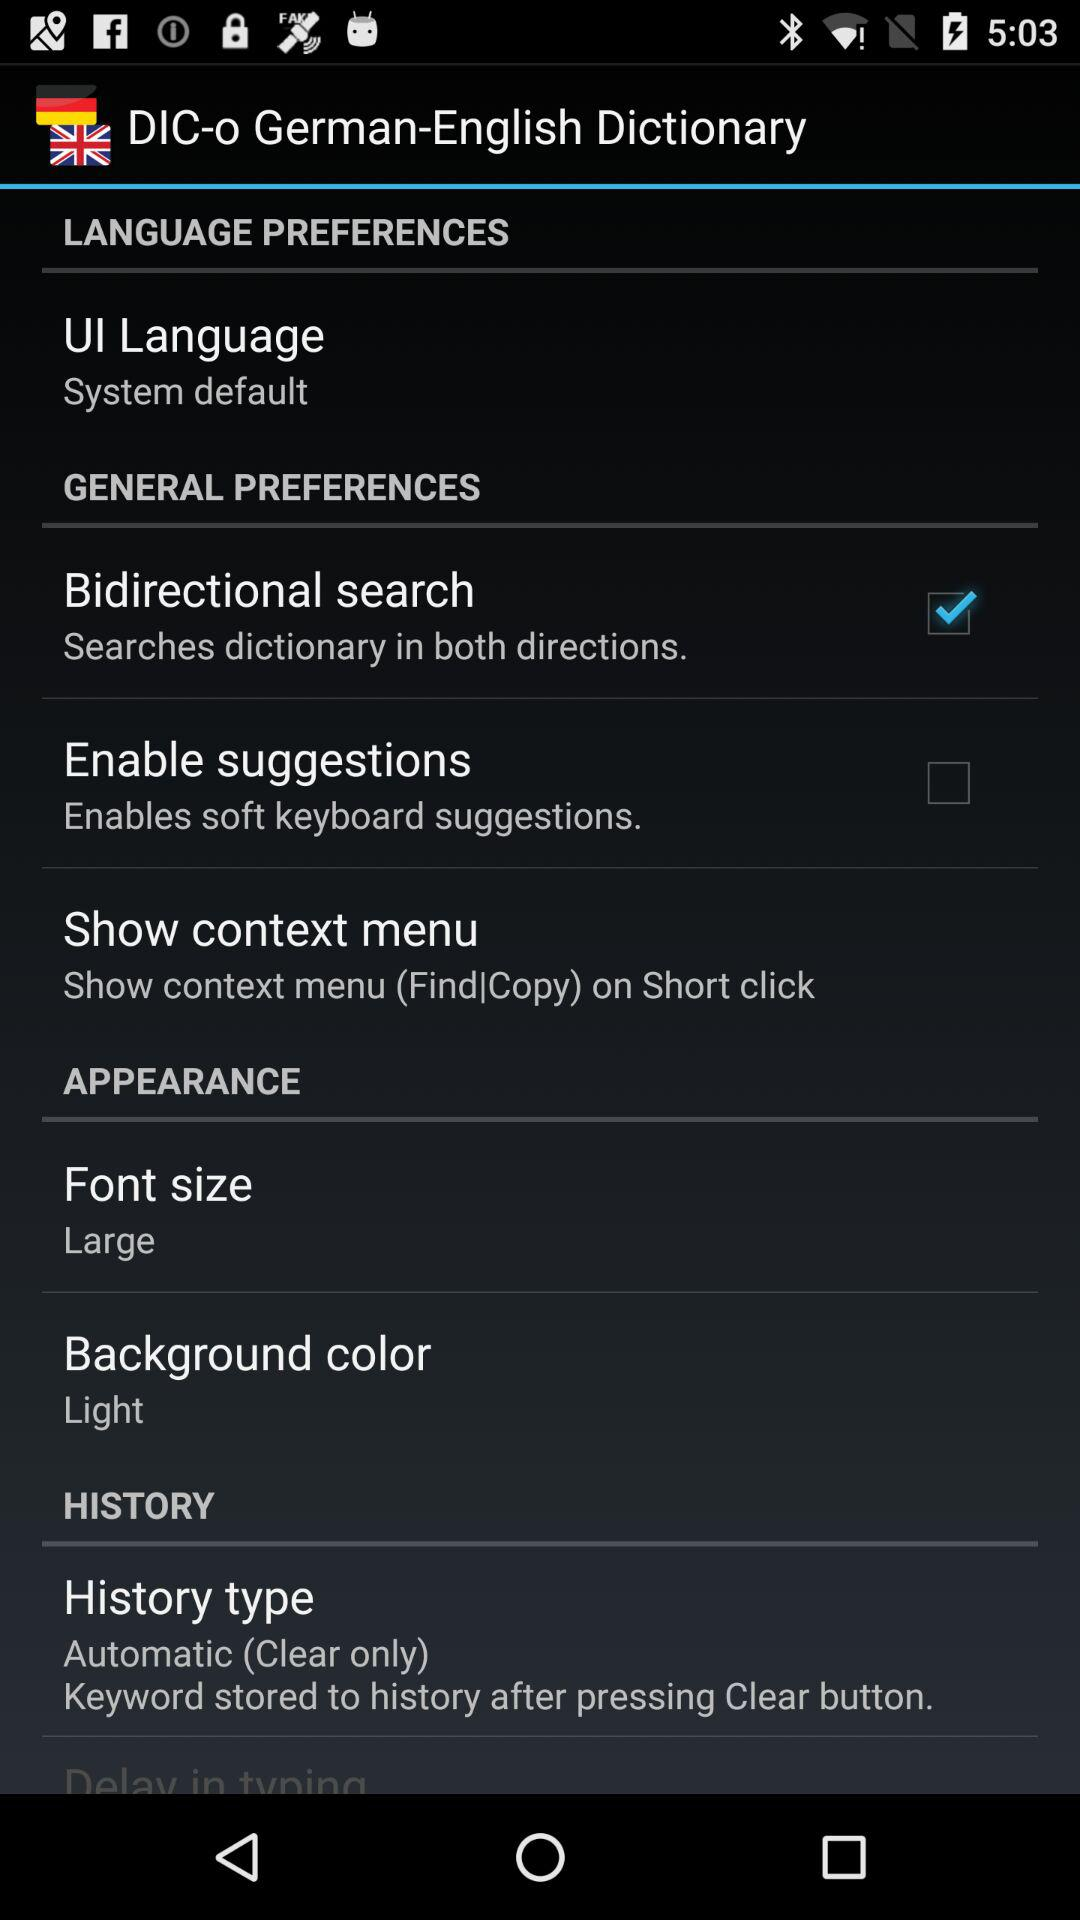What is the background color? The background color is "Light". 